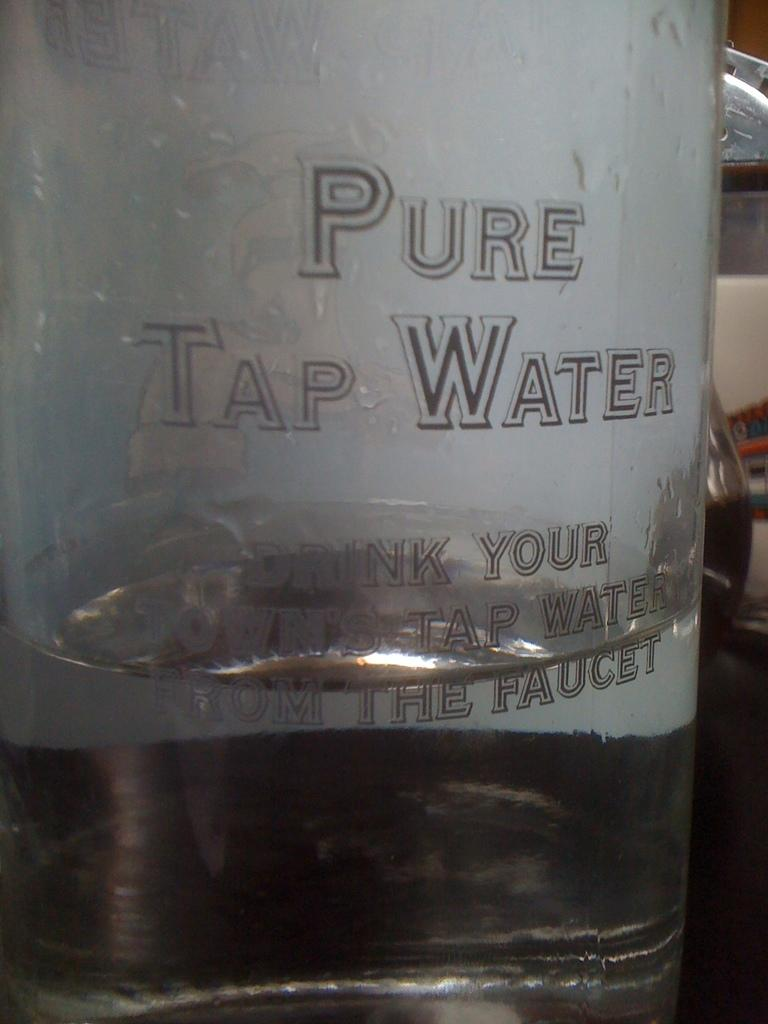<image>
Provide a brief description of the given image. a bottle of water labeled 'pure tap water' 